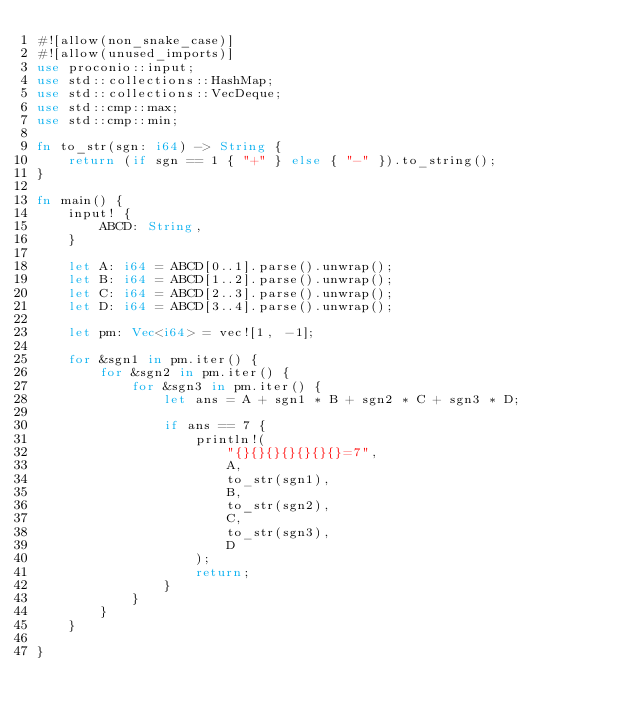<code> <loc_0><loc_0><loc_500><loc_500><_Rust_>#![allow(non_snake_case)]
#![allow(unused_imports)]
use proconio::input;
use std::collections::HashMap;
use std::collections::VecDeque;
use std::cmp::max;
use std::cmp::min;

fn to_str(sgn: i64) -> String {
    return (if sgn == 1 { "+" } else { "-" }).to_string();
}

fn main() {
    input! {
        ABCD: String,
    }

    let A: i64 = ABCD[0..1].parse().unwrap();
    let B: i64 = ABCD[1..2].parse().unwrap();
    let C: i64 = ABCD[2..3].parse().unwrap();
    let D: i64 = ABCD[3..4].parse().unwrap();

    let pm: Vec<i64> = vec![1, -1];

    for &sgn1 in pm.iter() {
        for &sgn2 in pm.iter() {
            for &sgn3 in pm.iter() {
                let ans = A + sgn1 * B + sgn2 * C + sgn3 * D;

                if ans == 7 {
                    println!(
                        "{}{}{}{}{}{}{}=7",
                        A,
                        to_str(sgn1),
                        B,
                        to_str(sgn2),
                        C,
                        to_str(sgn3),
                        D
                    );
                    return;
                }
            }
        }
    }

}
</code> 